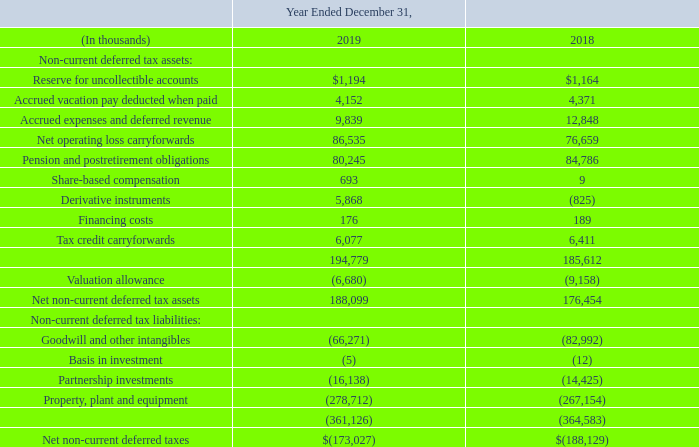Deferred Taxes The components of the net deferred tax liability are as follows:
Deferred income taxes are provided for the temporary differences between assets and liabilities recognized for financial reporting purposes and assets and liabilities recognized for tax purposes. The ultimate realization of deferred tax assets depends upon taxable income during the future periods in which those temporary differences become deductible.
To determine whether deferred tax assets can be realized, management assesses whether it is more likely than not that some portion or all of the deferred tax assets will not be realized, taking into consideration the scheduled reversal of deferred tax liabilities, projected future taxable income and tax-planning strategies.
Consolidated and its wholly owned subsidiaries, which file a consolidated federal income tax return, estimates it has available federal NOL carryforwards as of December 31, 2019 of $349.5 million and related deferred tax assets of $73.4 million.
The federal NOL carryforwards for tax years beginning after December 31, 2017 of $60.7 million and related deferred tax assets of $12.8 million can be carried forward indefinitely. The federal NOL carryforwards for the tax years prior to December 31, 2017 of $288.8 million and related deferred tax assets of $60.6 million expire in 2026 to 2035.
ETFL, a nonconsolidated subsidiary for federal income tax return purposes, estimates it has available NOL carryforwards as of December 31, 2019 of $1.0 million and related deferred tax assets of $0.2 million. ETFL’s federal NOL carryforwards are for the tax years prior to December 31, 2017 and expire in 2021 to 2024.
We estimate that we have available state NOL carryforwards as of December 31, 2019 of $758.5 million and related deferred tax assets of $16.7 million. The state NOL carryforwards expire from 2020 to 2039. Management believes that it is more likely than not that we will not be able to realize state NOL carryforwards of $80.3 million and related deferred tax asset of $5.2 million and has placed a valuation allowance on this amount.
The related NOL carryforwards expire from 2020 to 2037. If or when recognized, the tax benefits related to any reversal of the valuation allowance will be accounted for as a reduction of income tax expense.
The enacted Tax Act repeals the federal alternative minimum tax (“AMT”) regime for tax years beginning after December 31, 2017. We have available AMT credit carryforwards as of December 31, 2019 of $1.5 million, which will be fully refundable with the filing of the 2019 federal income tax return in 2020.
We estimate that we have available state tax credit carryforwards as of December 31, 2019 of $7.7 million and related deferred tax assets of $6.1 million. The state tax credit carryforwards are limited annually and expire from 2020 to 2029.
Management believes that it is more likely than not that we will not be able to realize state tax carryforwards of $1.8 million and related deferred tax asset of $1.5 million and has placed a valuation allowance on this amount. The related state tax credit carryforwards expire from 2020 to 2024. If or when recognized, the tax benefits related to any reversal of the valuation allowance will be accounted for as a reduction of income tax expense.
What is the Reserve for uncollectible accounts for 2018?
Answer scale should be: thousand. $1,164. What determine whether deferred tax assets can be realized or not realized? Taking into consideration the scheduled reversal of deferred tax liabilities, projected future taxable income and tax-planning strategies. What was available state tax credit carryforwards as of December 31, 2019? We have available state tax credit carryforwards as of december 31, 2019 of $7.7 million and related deferred tax assets of $6.1 million. What is the increase/ (decrease) in Reserve for uncollectible accounts from 2018 to 2019?
Answer scale should be: thousand. 1,194-1,164
Answer: 30. What is the increase/ (decrease) in Accrued vacation pay deducted when paid from 2018 to 2019?
Answer scale should be: thousand. 4,152-4,371
Answer: -219. What is the increase/ (decrease) in Accrued expenses and deferred revenue from 2018 to 2019?
Answer scale should be: thousand. 9,839-12,848
Answer: -3009. 